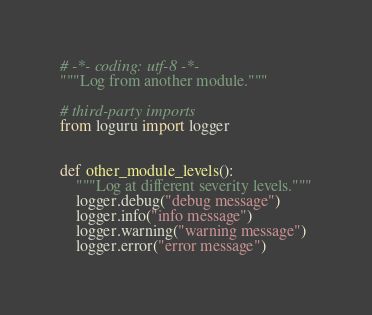<code> <loc_0><loc_0><loc_500><loc_500><_Python_># -*- coding: utf-8 -*-
"""Log from another module."""

# third-party imports
from loguru import logger


def other_module_levels():
    """Log at different severity levels."""
    logger.debug("debug message")
    logger.info("info message")
    logger.warning("warning message")
    logger.error("error message")
</code> 